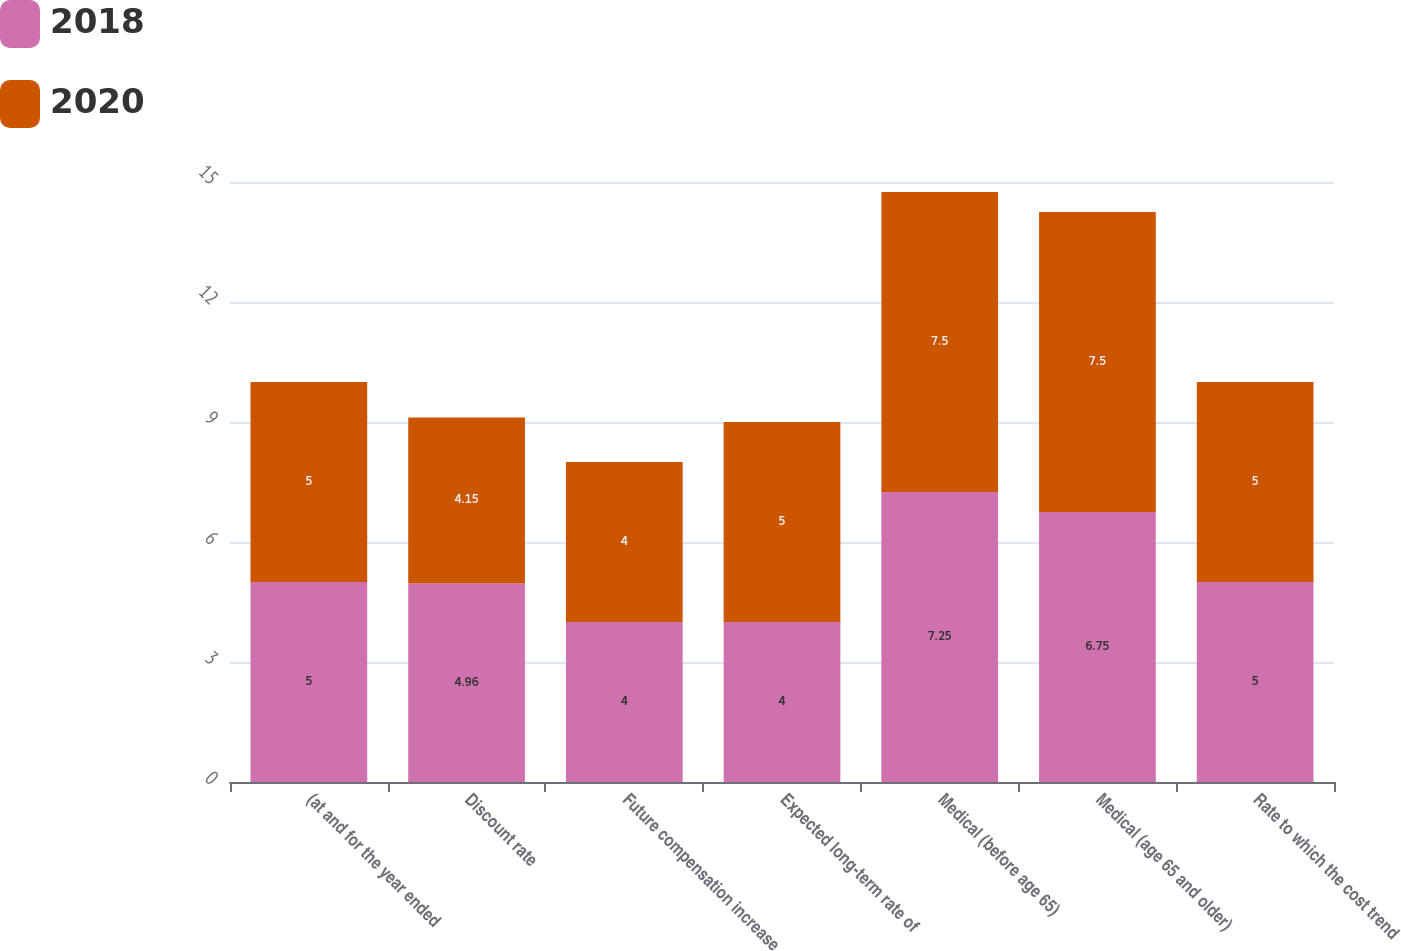<chart> <loc_0><loc_0><loc_500><loc_500><stacked_bar_chart><ecel><fcel>(at and for the year ended<fcel>Discount rate<fcel>Future compensation increase<fcel>Expected long-term rate of<fcel>Medical (before age 65)<fcel>Medical (age 65 and older)<fcel>Rate to which the cost trend<nl><fcel>2018<fcel>5<fcel>4.96<fcel>4<fcel>4<fcel>7.25<fcel>6.75<fcel>5<nl><fcel>2020<fcel>5<fcel>4.15<fcel>4<fcel>5<fcel>7.5<fcel>7.5<fcel>5<nl></chart> 